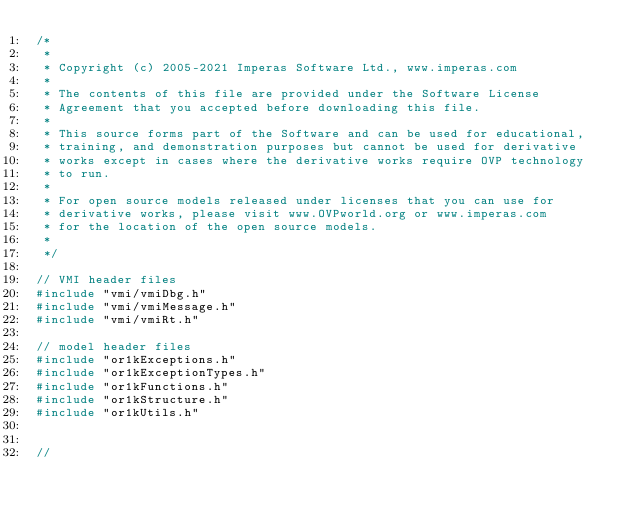Convert code to text. <code><loc_0><loc_0><loc_500><loc_500><_C_>/*
 *
 * Copyright (c) 2005-2021 Imperas Software Ltd., www.imperas.com
 *
 * The contents of this file are provided under the Software License
 * Agreement that you accepted before downloading this file.
 *
 * This source forms part of the Software and can be used for educational,
 * training, and demonstration purposes but cannot be used for derivative
 * works except in cases where the derivative works require OVP technology
 * to run.
 *
 * For open source models released under licenses that you can use for
 * derivative works, please visit www.OVPworld.org or www.imperas.com
 * for the location of the open source models.
 *
 */

// VMI header files
#include "vmi/vmiDbg.h"
#include "vmi/vmiMessage.h"
#include "vmi/vmiRt.h"

// model header files
#include "or1kExceptions.h"
#include "or1kExceptionTypes.h"
#include "or1kFunctions.h"
#include "or1kStructure.h"
#include "or1kUtils.h"


//</code> 